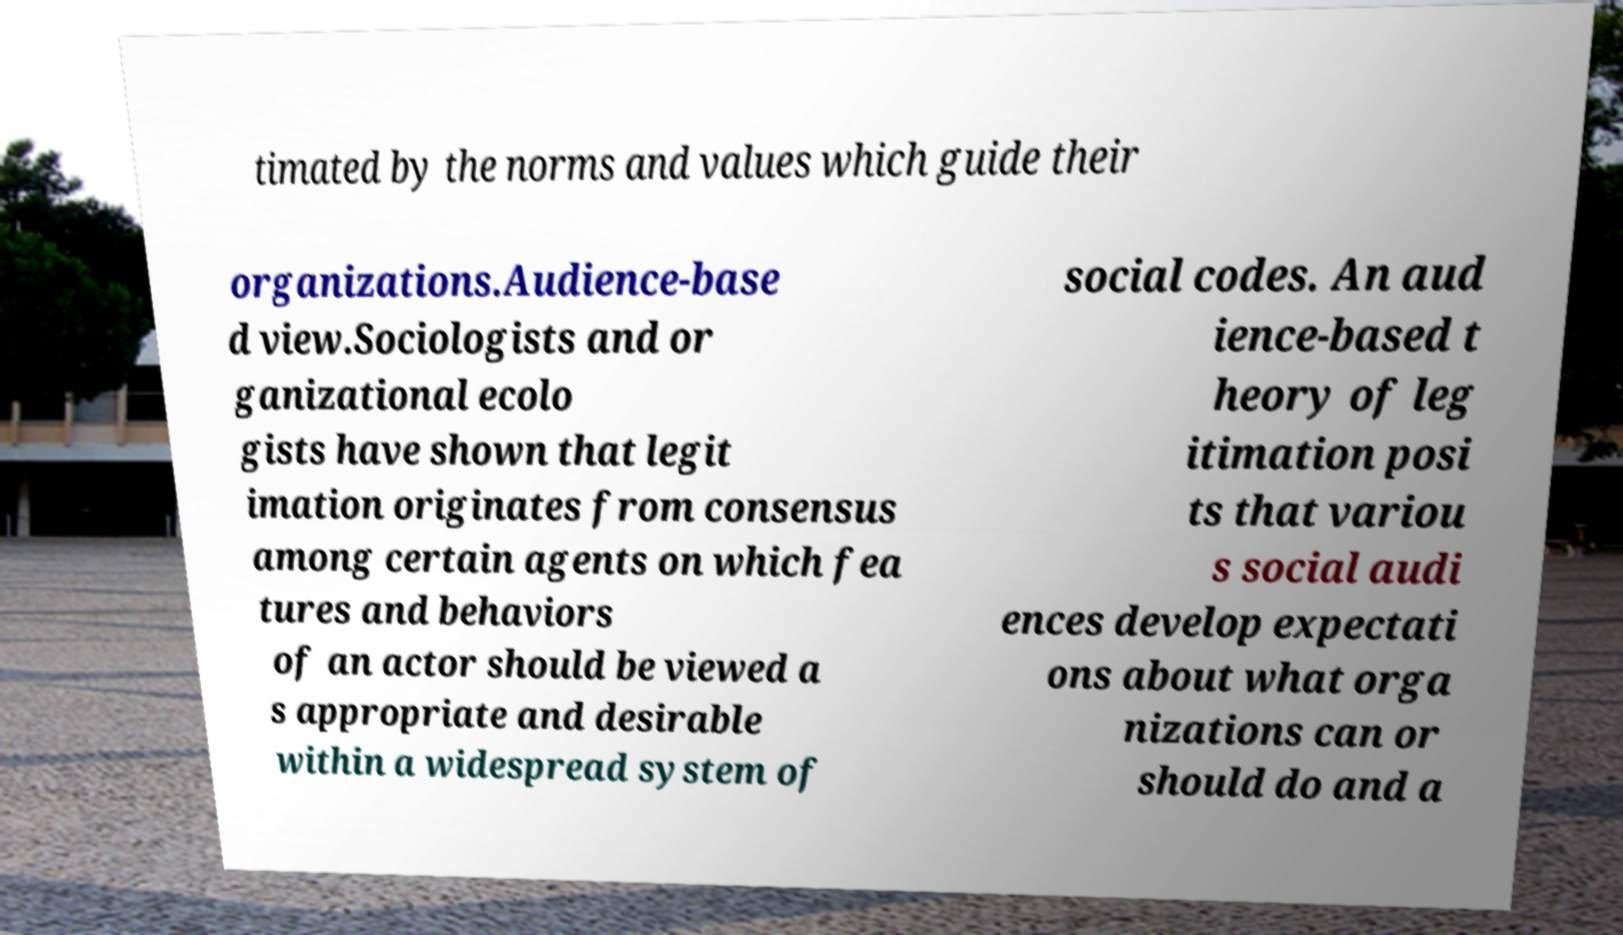Could you assist in decoding the text presented in this image and type it out clearly? timated by the norms and values which guide their organizations.Audience-base d view.Sociologists and or ganizational ecolo gists have shown that legit imation originates from consensus among certain agents on which fea tures and behaviors of an actor should be viewed a s appropriate and desirable within a widespread system of social codes. An aud ience-based t heory of leg itimation posi ts that variou s social audi ences develop expectati ons about what orga nizations can or should do and a 